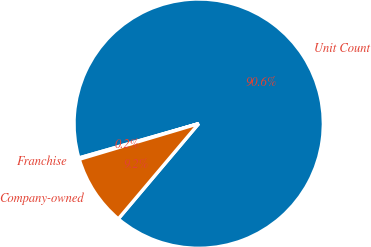Convert chart to OTSL. <chart><loc_0><loc_0><loc_500><loc_500><pie_chart><fcel>Unit Count<fcel>Franchise<fcel>Company-owned<nl><fcel>90.6%<fcel>0.18%<fcel>9.22%<nl></chart> 